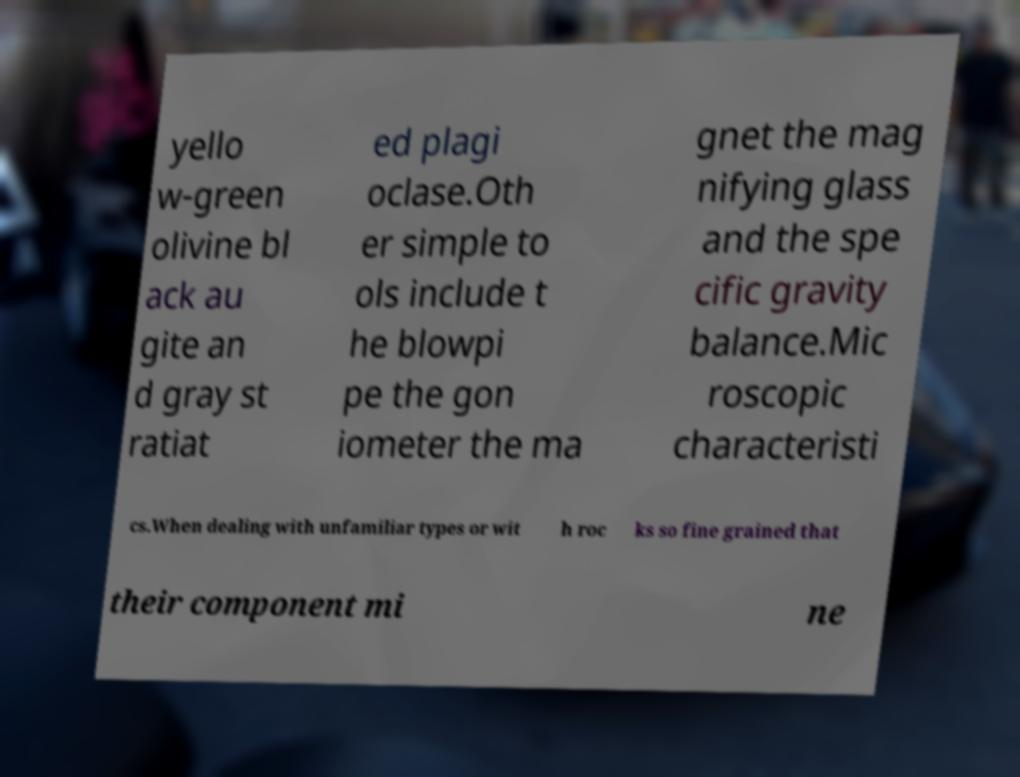What messages or text are displayed in this image? I need them in a readable, typed format. yello w-green olivine bl ack au gite an d gray st ratiat ed plagi oclase.Oth er simple to ols include t he blowpi pe the gon iometer the ma gnet the mag nifying glass and the spe cific gravity balance.Mic roscopic characteristi cs.When dealing with unfamiliar types or wit h roc ks so fine grained that their component mi ne 